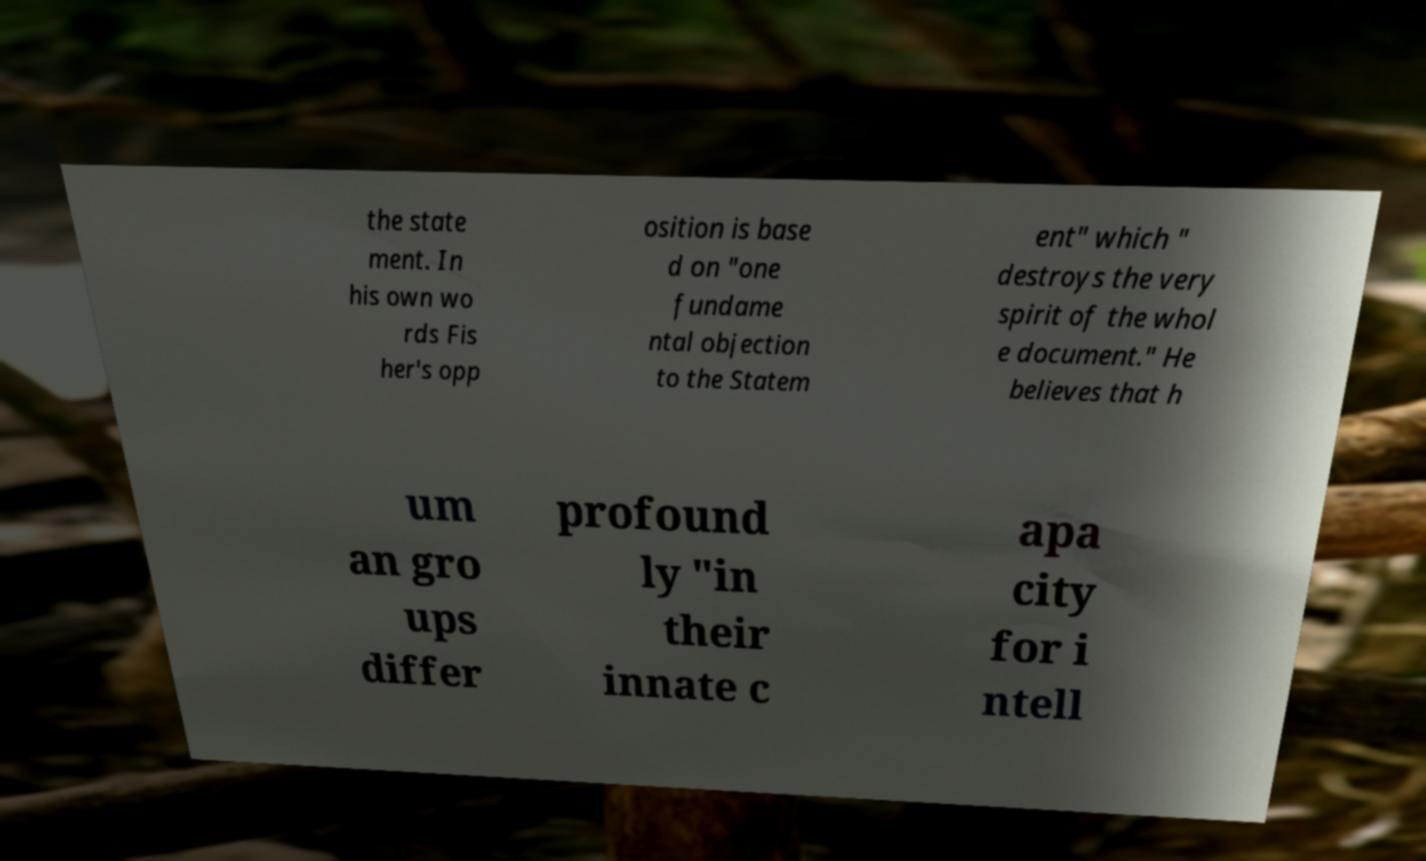Please read and relay the text visible in this image. What does it say? the state ment. In his own wo rds Fis her's opp osition is base d on "one fundame ntal objection to the Statem ent" which " destroys the very spirit of the whol e document." He believes that h um an gro ups differ profound ly "in their innate c apa city for i ntell 